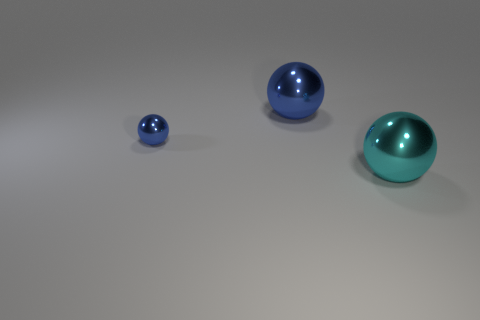Add 2 big cyan things. How many objects exist? 5 Subtract all small blue shiny balls. Subtract all large cyan things. How many objects are left? 1 Add 3 blue objects. How many blue objects are left? 5 Add 2 small blue objects. How many small blue objects exist? 3 Subtract 0 brown blocks. How many objects are left? 3 